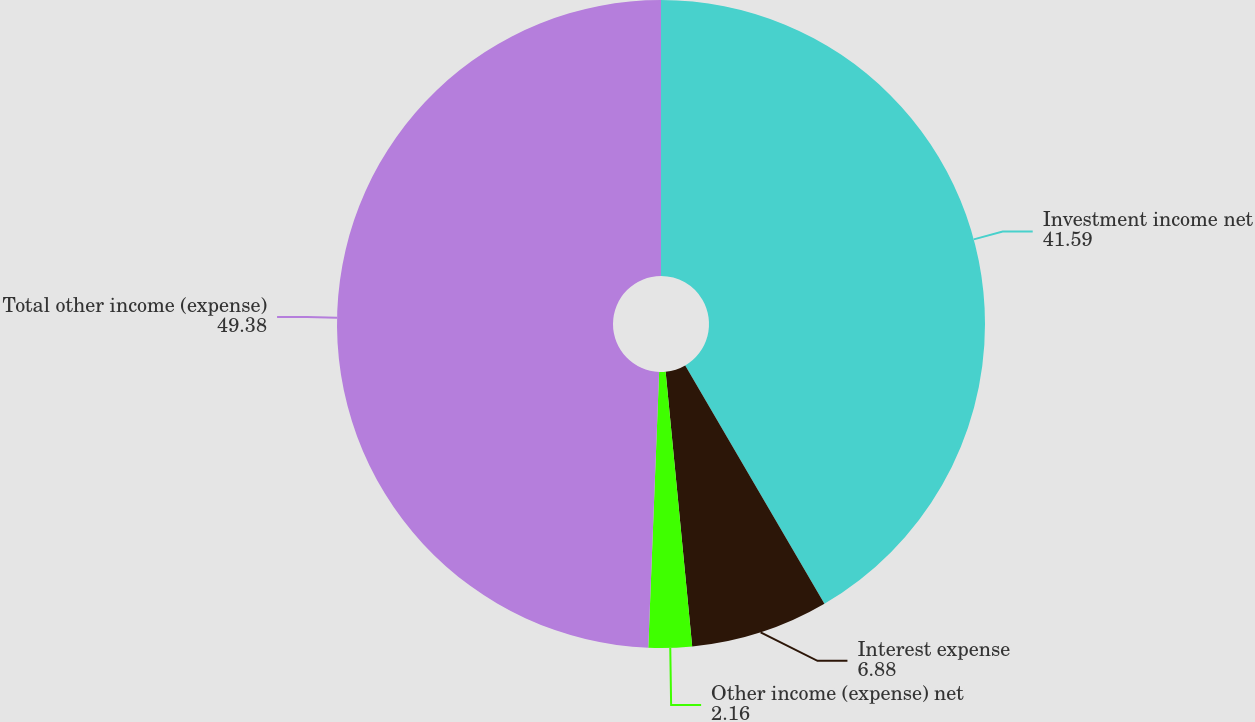Convert chart. <chart><loc_0><loc_0><loc_500><loc_500><pie_chart><fcel>Investment income net<fcel>Interest expense<fcel>Other income (expense) net<fcel>Total other income (expense)<nl><fcel>41.59%<fcel>6.88%<fcel>2.16%<fcel>49.38%<nl></chart> 